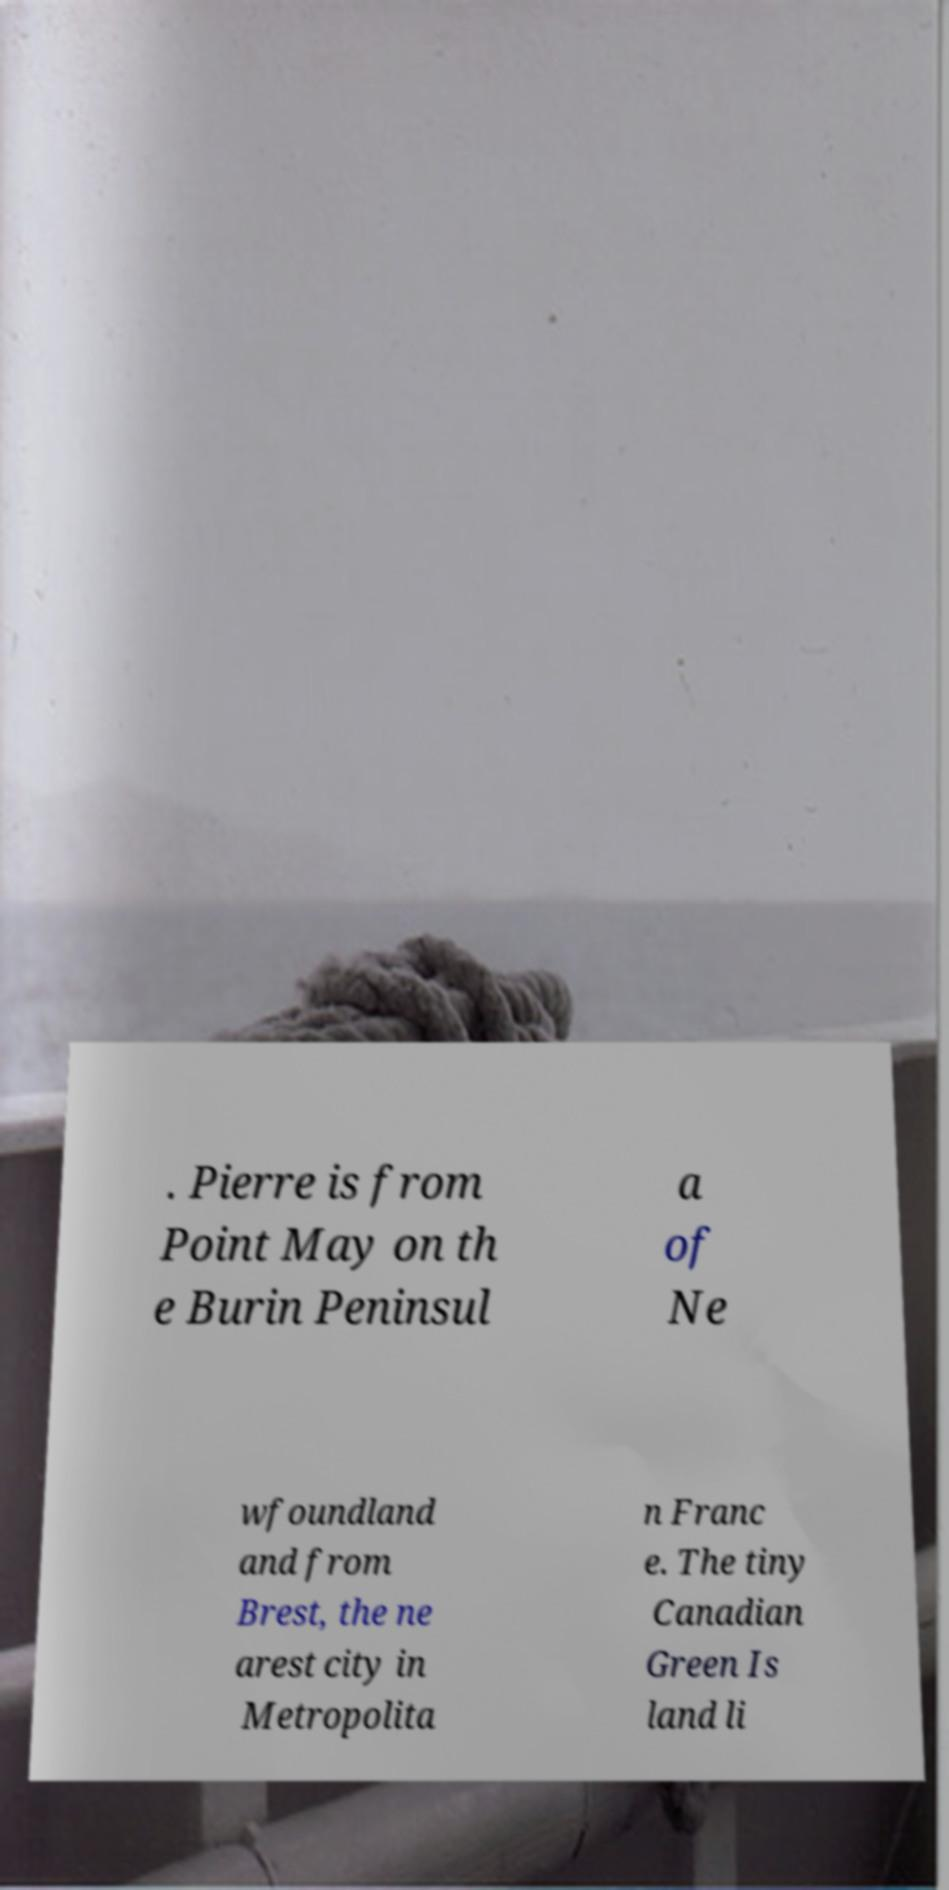Could you extract and type out the text from this image? . Pierre is from Point May on th e Burin Peninsul a of Ne wfoundland and from Brest, the ne arest city in Metropolita n Franc e. The tiny Canadian Green Is land li 